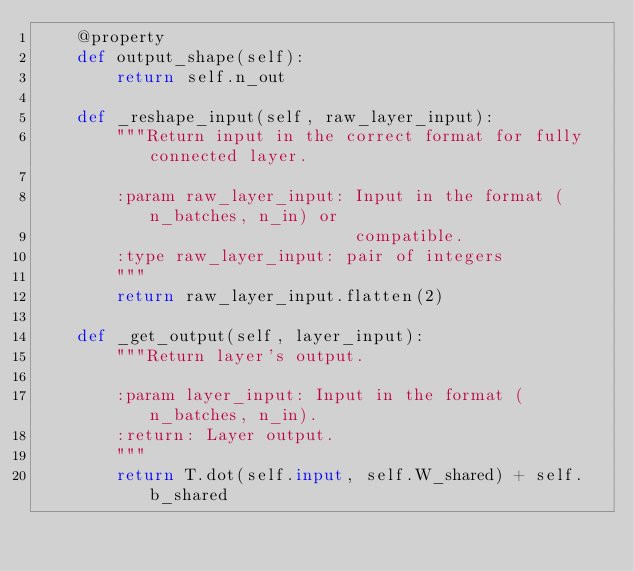Convert code to text. <code><loc_0><loc_0><loc_500><loc_500><_Python_>    @property
    def output_shape(self):
        return self.n_out

    def _reshape_input(self, raw_layer_input):
        """Return input in the correct format for fully connected layer.

        :param raw_layer_input: Input in the format (n_batches, n_in) or
                                compatible.
        :type raw_layer_input: pair of integers
        """
        return raw_layer_input.flatten(2)

    def _get_output(self, layer_input):
        """Return layer's output.

        :param layer_input: Input in the format (n_batches, n_in).
        :return: Layer output.
        """
        return T.dot(self.input, self.W_shared) + self.b_shared
</code> 